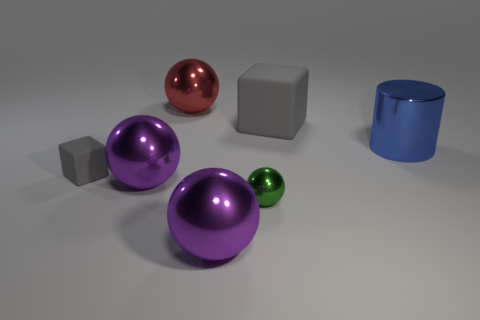Subtract all brown balls. Subtract all yellow cylinders. How many balls are left? 4 Add 3 tiny shiny objects. How many objects exist? 10 Subtract all cylinders. How many objects are left? 6 Subtract 0 blue blocks. How many objects are left? 7 Subtract all small gray metal objects. Subtract all metal things. How many objects are left? 2 Add 7 large blocks. How many large blocks are left? 8 Add 1 tiny rubber spheres. How many tiny rubber spheres exist? 1 